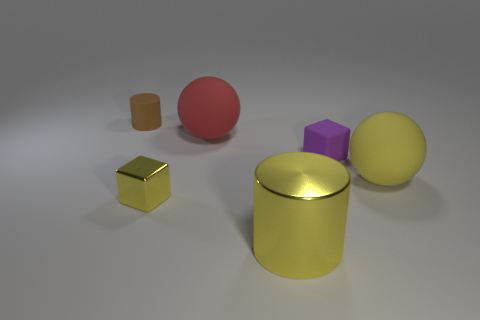What is the material of the other thing that is the same shape as the yellow matte object?
Keep it short and to the point. Rubber. What number of large yellow matte objects are in front of the big ball to the left of the cylinder that is to the right of the brown matte cylinder?
Keep it short and to the point. 1. Is there anything else of the same color as the large cylinder?
Your response must be concise. Yes. How many objects are left of the big red matte object and right of the tiny cylinder?
Make the answer very short. 1. Is the size of the yellow metallic thing that is in front of the yellow block the same as the brown cylinder behind the yellow ball?
Ensure brevity in your answer.  No. How many things are either small yellow blocks on the left side of the big metallic cylinder or large green matte cylinders?
Offer a very short reply. 1. What is the sphere that is left of the large cylinder made of?
Make the answer very short. Rubber. What is the material of the small yellow cube?
Make the answer very short. Metal. What material is the big yellow object behind the large yellow thing in front of the large thing on the right side of the tiny purple rubber thing?
Your answer should be very brief. Rubber. Is there any other thing that is made of the same material as the tiny brown cylinder?
Give a very brief answer. Yes. 